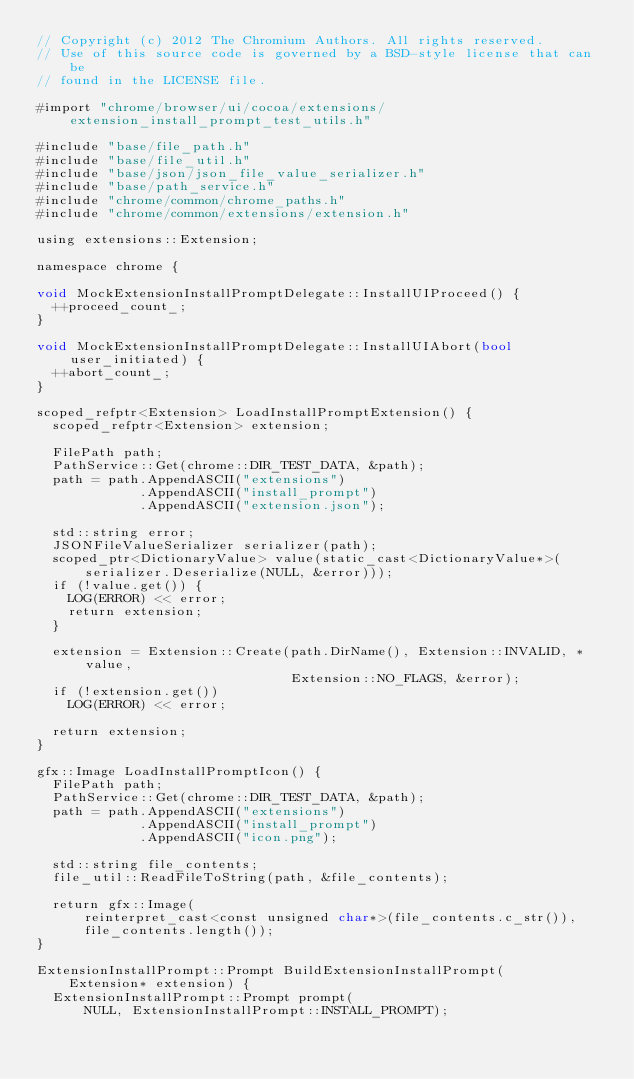Convert code to text. <code><loc_0><loc_0><loc_500><loc_500><_ObjectiveC_>// Copyright (c) 2012 The Chromium Authors. All rights reserved.
// Use of this source code is governed by a BSD-style license that can be
// found in the LICENSE file.

#import "chrome/browser/ui/cocoa/extensions/extension_install_prompt_test_utils.h"

#include "base/file_path.h"
#include "base/file_util.h"
#include "base/json/json_file_value_serializer.h"
#include "base/path_service.h"
#include "chrome/common/chrome_paths.h"
#include "chrome/common/extensions/extension.h"

using extensions::Extension;

namespace chrome {

void MockExtensionInstallPromptDelegate::InstallUIProceed() {
  ++proceed_count_;
}

void MockExtensionInstallPromptDelegate::InstallUIAbort(bool user_initiated) {
  ++abort_count_;
}

scoped_refptr<Extension> LoadInstallPromptExtension() {
  scoped_refptr<Extension> extension;

  FilePath path;
  PathService::Get(chrome::DIR_TEST_DATA, &path);
  path = path.AppendASCII("extensions")
             .AppendASCII("install_prompt")
             .AppendASCII("extension.json");

  std::string error;
  JSONFileValueSerializer serializer(path);
  scoped_ptr<DictionaryValue> value(static_cast<DictionaryValue*>(
      serializer.Deserialize(NULL, &error)));
  if (!value.get()) {
    LOG(ERROR) << error;
    return extension;
  }

  extension = Extension::Create(path.DirName(), Extension::INVALID, *value,
                                Extension::NO_FLAGS, &error);
  if (!extension.get())
    LOG(ERROR) << error;

  return extension;
}

gfx::Image LoadInstallPromptIcon() {
  FilePath path;
  PathService::Get(chrome::DIR_TEST_DATA, &path);
  path = path.AppendASCII("extensions")
             .AppendASCII("install_prompt")
             .AppendASCII("icon.png");

  std::string file_contents;
  file_util::ReadFileToString(path, &file_contents);

  return gfx::Image(
      reinterpret_cast<const unsigned char*>(file_contents.c_str()),
      file_contents.length());
}

ExtensionInstallPrompt::Prompt BuildExtensionInstallPrompt(
    Extension* extension) {
  ExtensionInstallPrompt::Prompt prompt(
      NULL, ExtensionInstallPrompt::INSTALL_PROMPT);</code> 